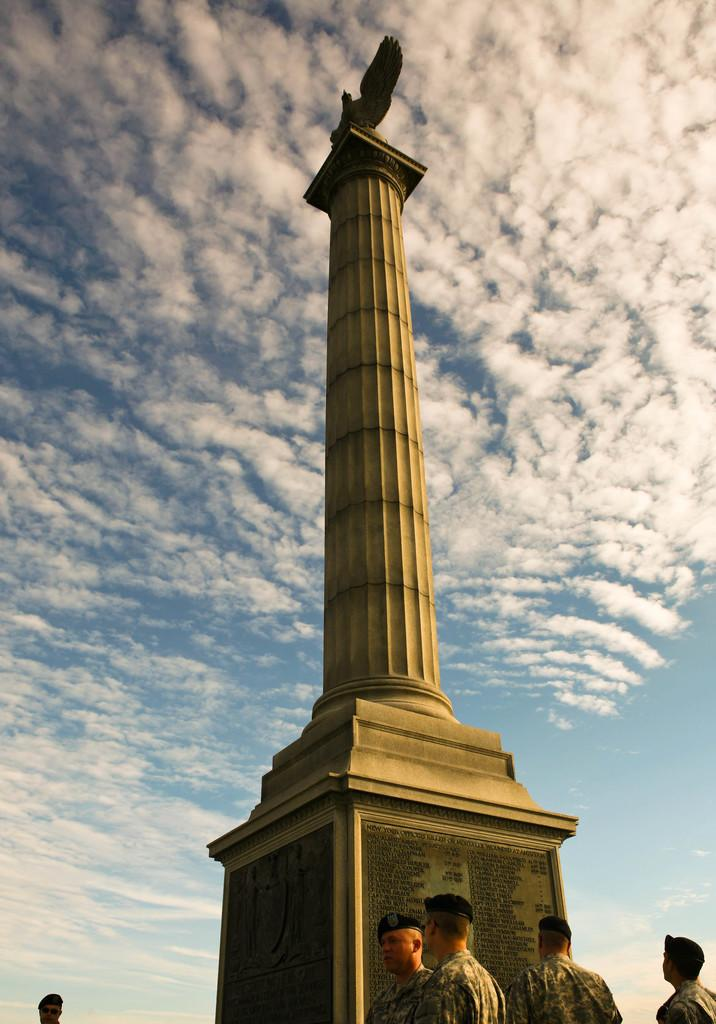What can be seen in the foreground of the picture? There are soldiers in the foreground of the picture. What is located in the center of the picture? There is a tower in the center of the picture. How would you describe the sky in the image? The sky is partly cloudy, and it is sunny in the image. What color is the bead that the soldier is holding in the image? There is no bead visible in the image; the soldiers are not holding any beads. In which direction are the soldiers marching in the image? The image does not provide information about the direction in which the soldiers are marching. 